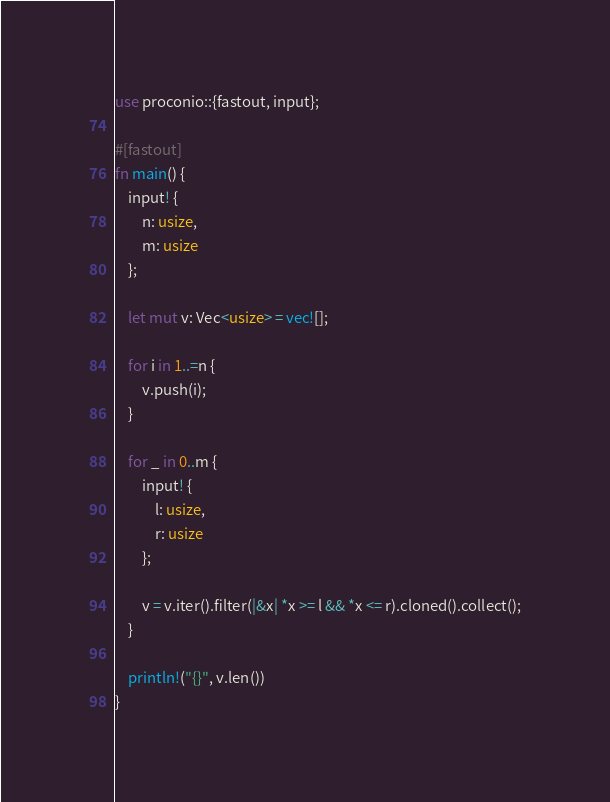<code> <loc_0><loc_0><loc_500><loc_500><_Rust_>use proconio::{fastout, input};

#[fastout]
fn main() {
    input! {
        n: usize,
        m: usize
    };

    let mut v: Vec<usize> = vec![];

    for i in 1..=n {
        v.push(i);
    }

    for _ in 0..m {
        input! {
            l: usize,
            r: usize
        };

        v = v.iter().filter(|&x| *x >= l && *x <= r).cloned().collect();
    }

    println!("{}", v.len())
}
</code> 